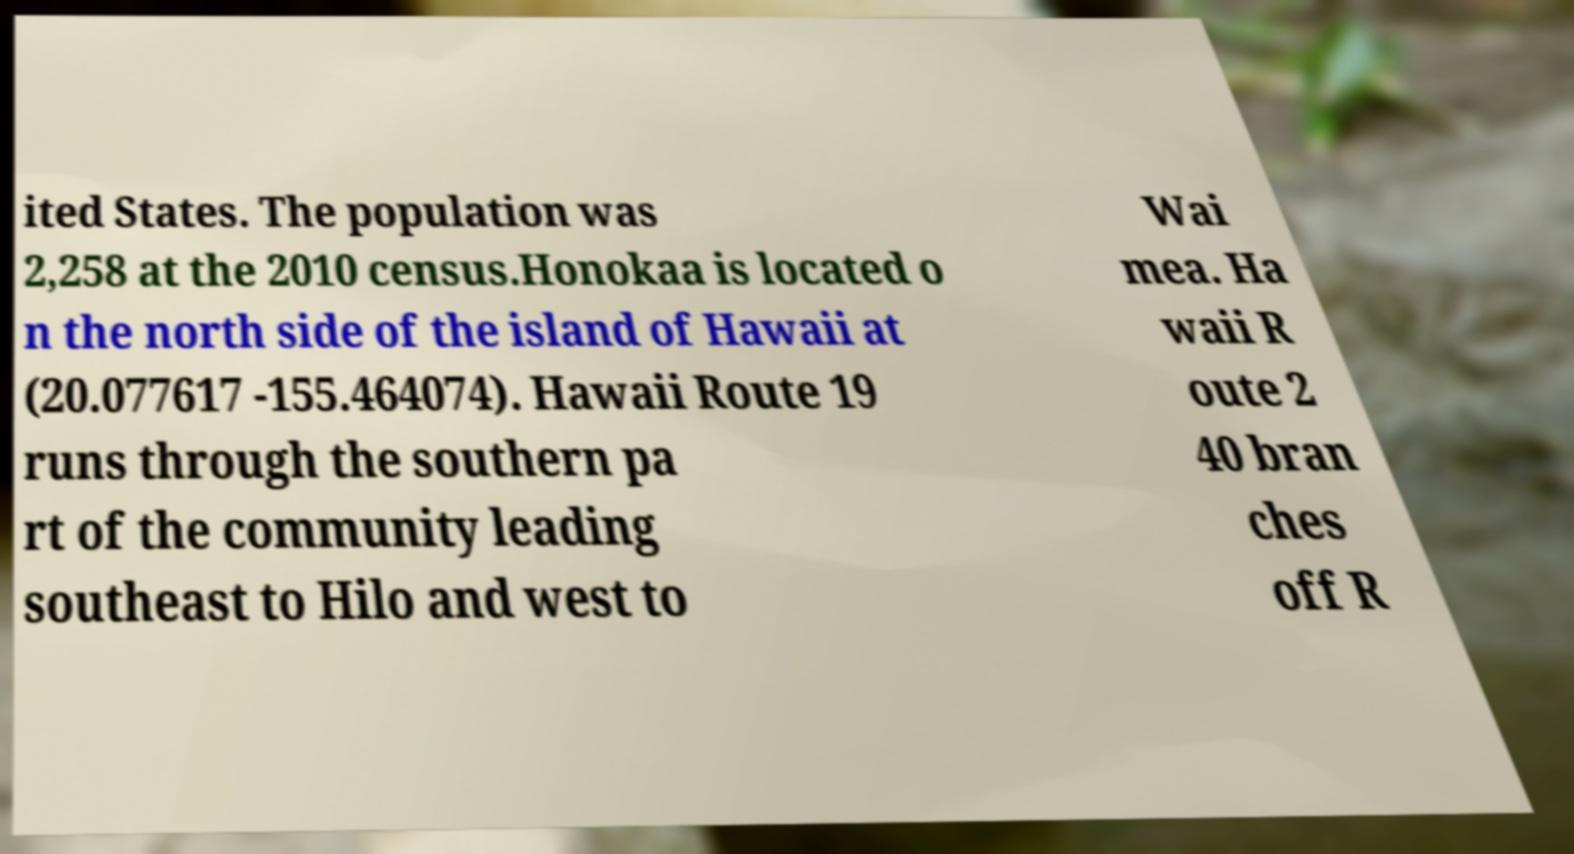Could you assist in decoding the text presented in this image and type it out clearly? ited States. The population was 2,258 at the 2010 census.Honokaa is located o n the north side of the island of Hawaii at (20.077617 -155.464074). Hawaii Route 19 runs through the southern pa rt of the community leading southeast to Hilo and west to Wai mea. Ha waii R oute 2 40 bran ches off R 